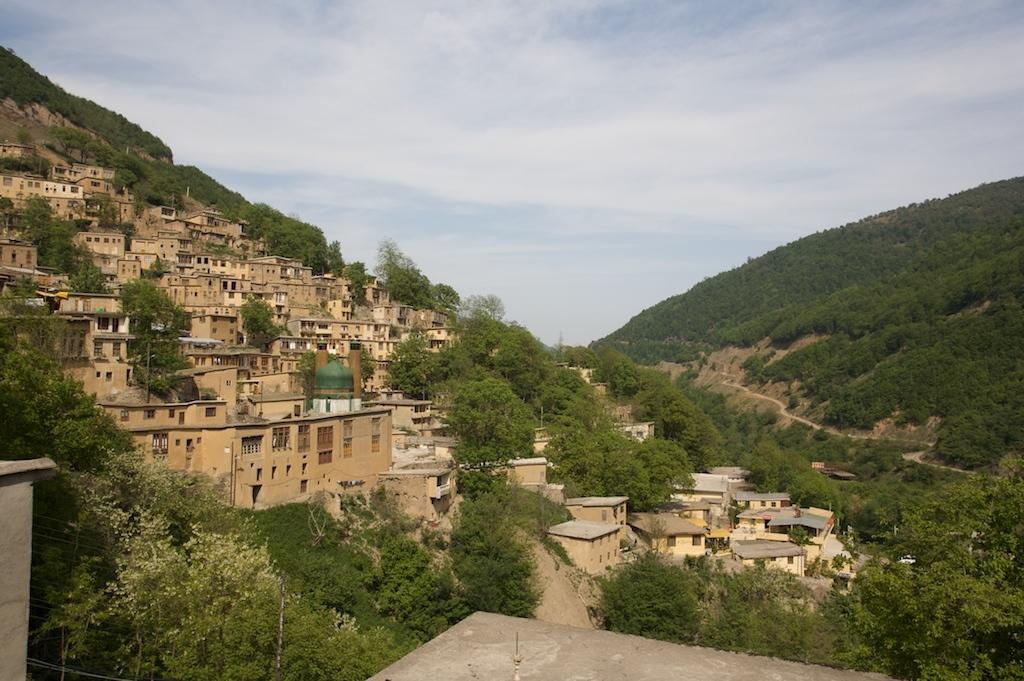What type of natural feature can be seen in the image? There are hills in the image. What man-made structures are present in the image? There are buildings in the image. What type of vegetation is visible in the image? There are trees in the image. What is visible in the background of the image? The sky is visible in the image. What can be seen in the sky in the image? There are clouds in the sky. What type of button can be seen on the roof of the building in the image? There is no button visible on the roof of any building in the image. What type of cup is being used to collect rainwater from the trees in the image? There is no cup being used to collect rainwater from the trees in the image, as there is no indication of rain or water collection. 